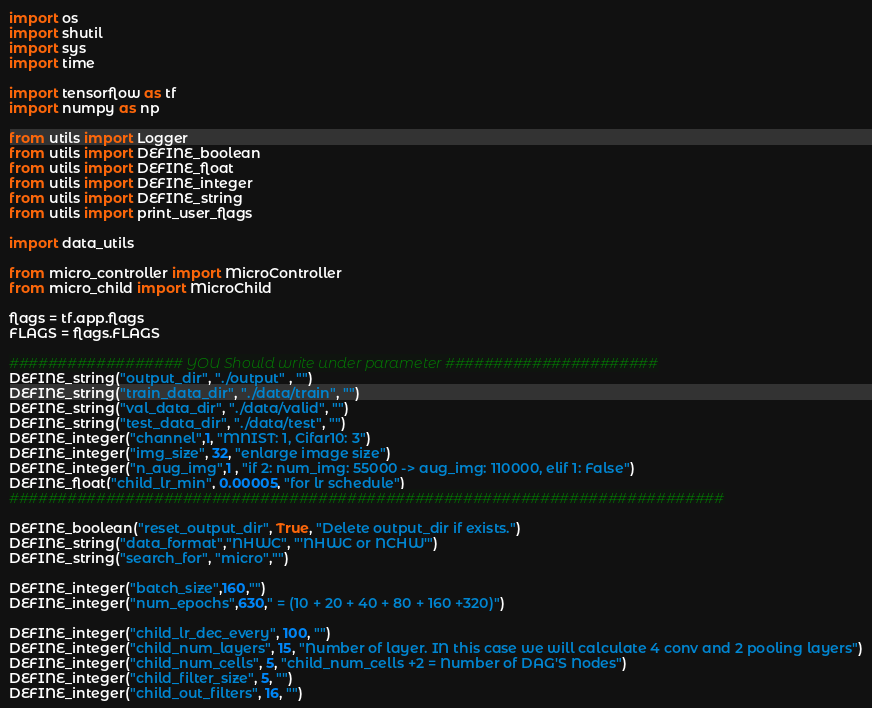<code> <loc_0><loc_0><loc_500><loc_500><_Python_>import os
import shutil
import sys
import time

import tensorflow as tf
import numpy as np

from utils import Logger
from utils import DEFINE_boolean
from utils import DEFINE_float
from utils import DEFINE_integer
from utils import DEFINE_string
from utils import print_user_flags

import data_utils

from micro_controller import MicroController
from micro_child import MicroChild

flags = tf.app.flags
FLAGS = flags.FLAGS

################## YOU Should write under parameter ######################
DEFINE_string("output_dir", "./output" , "")
DEFINE_string("train_data_dir", "./data/train", "")
DEFINE_string("val_data_dir", "./data/valid", "")
DEFINE_string("test_data_dir", "./data/test", "")
DEFINE_integer("channel",1, "MNIST: 1, Cifar10: 3")
DEFINE_integer("img_size", 32, "enlarge image size")
DEFINE_integer("n_aug_img",1 , "if 2: num_img: 55000 -> aug_img: 110000, elif 1: False")
DEFINE_float("child_lr_min", 0.00005, "for lr schedule")
##########################################################################

DEFINE_boolean("reset_output_dir", True, "Delete output_dir if exists.")
DEFINE_string("data_format","NHWC", "'NHWC or NCHW'")
DEFINE_string("search_for", "micro","")

DEFINE_integer("batch_size",160,"")
DEFINE_integer("num_epochs",630," = (10 + 20 + 40 + 80 + 160 +320)")

DEFINE_integer("child_lr_dec_every", 100, "")
DEFINE_integer("child_num_layers", 15, "Number of layer. IN this case we will calculate 4 conv and 2 pooling layers")
DEFINE_integer("child_num_cells", 5, "child_num_cells +2 = Number of DAG'S Nodes")
DEFINE_integer("child_filter_size", 5, "")
DEFINE_integer("child_out_filters", 16, "")</code> 